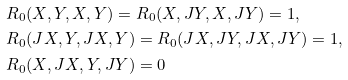<formula> <loc_0><loc_0><loc_500><loc_500>& R _ { 0 } ( X , Y , X , Y ) = R _ { 0 } ( X , J Y , X , J Y ) = 1 , \\ & R _ { 0 } ( J X , Y , J X , Y ) = R _ { 0 } ( J X , J Y , J X , J Y ) = 1 , \\ & R _ { 0 } ( X , J X , Y , J Y ) = 0</formula> 